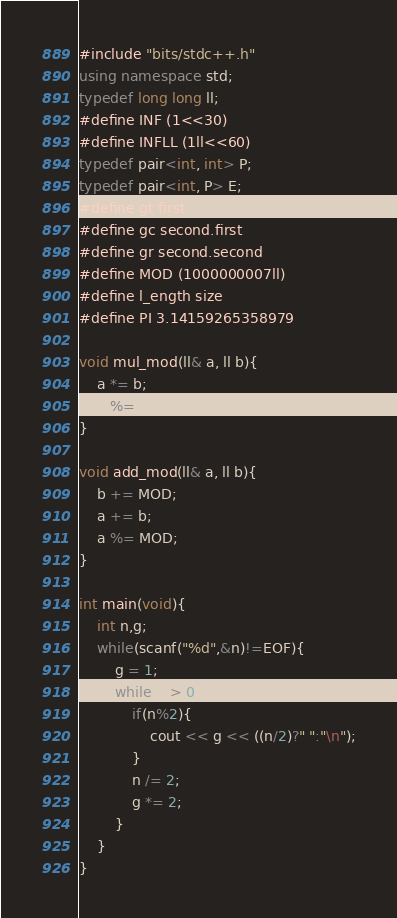Convert code to text. <code><loc_0><loc_0><loc_500><loc_500><_C++_>#include "bits/stdc++.h"
using namespace std;
typedef long long ll;
#define INF (1<<30)
#define INFLL (1ll<<60)
typedef pair<int, int> P;
typedef pair<int, P> E;
#define gt first
#define gc second.first
#define gr second.second
#define MOD (1000000007ll)
#define l_ength size
#define PI 3.14159265358979

void mul_mod(ll& a, ll b){
	a *= b;
	a %= MOD;
}

void add_mod(ll& a, ll b){
	b += MOD;
	a += b;
	a %= MOD;
}

int main(void){
	int n,g;
	while(scanf("%d",&n)!=EOF){
		g = 1;
		while(n > 0){
			if(n%2){
				cout << g << ((n/2)?" ":"\n");
			}
			n /= 2;
			g *= 2;
		}
	}
}

</code> 